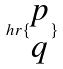Convert formula to latex. <formula><loc_0><loc_0><loc_500><loc_500>h r \{ \begin{matrix} p \\ q \end{matrix} \}</formula> 